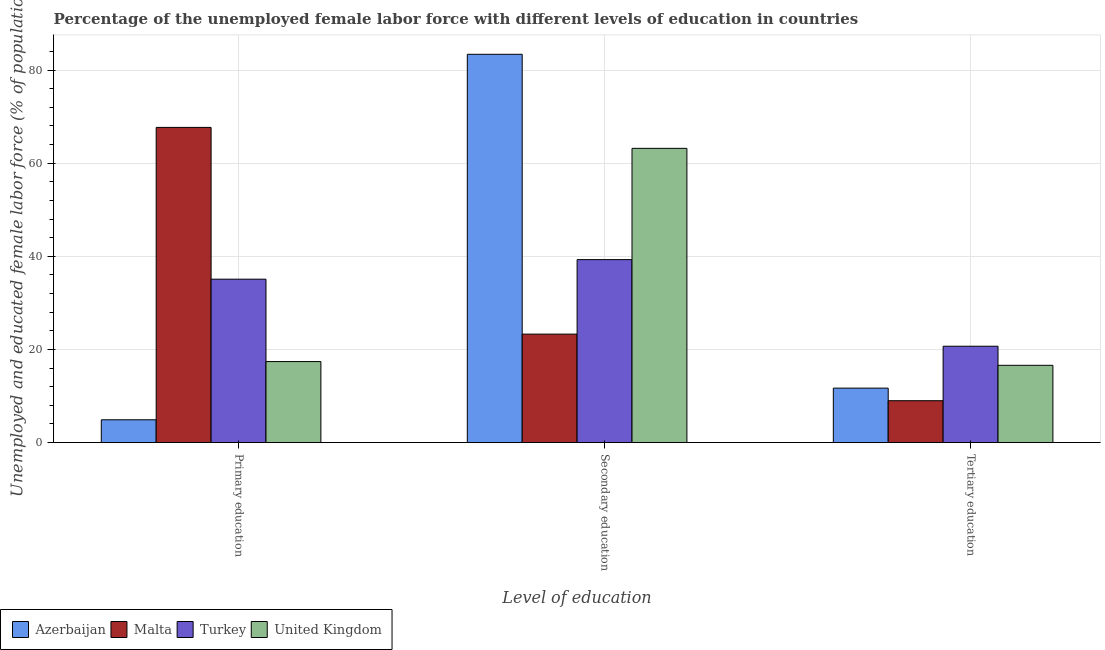Are the number of bars per tick equal to the number of legend labels?
Your response must be concise. Yes. Are the number of bars on each tick of the X-axis equal?
Offer a terse response. Yes. How many bars are there on the 3rd tick from the right?
Your response must be concise. 4. What is the label of the 3rd group of bars from the left?
Ensure brevity in your answer.  Tertiary education. What is the percentage of female labor force who received primary education in Azerbaijan?
Your response must be concise. 4.9. Across all countries, what is the maximum percentage of female labor force who received primary education?
Your answer should be very brief. 67.7. Across all countries, what is the minimum percentage of female labor force who received secondary education?
Ensure brevity in your answer.  23.3. In which country was the percentage of female labor force who received secondary education maximum?
Provide a short and direct response. Azerbaijan. In which country was the percentage of female labor force who received primary education minimum?
Provide a short and direct response. Azerbaijan. What is the total percentage of female labor force who received primary education in the graph?
Provide a succinct answer. 125.1. What is the difference between the percentage of female labor force who received primary education in Turkey and that in Malta?
Offer a terse response. -32.6. What is the difference between the percentage of female labor force who received tertiary education in Malta and the percentage of female labor force who received secondary education in United Kingdom?
Offer a very short reply. -54.2. What is the average percentage of female labor force who received tertiary education per country?
Your response must be concise. 14.5. What is the difference between the percentage of female labor force who received secondary education and percentage of female labor force who received tertiary education in United Kingdom?
Provide a short and direct response. 46.6. What is the ratio of the percentage of female labor force who received tertiary education in Malta to that in United Kingdom?
Your answer should be very brief. 0.54. What is the difference between the highest and the second highest percentage of female labor force who received primary education?
Your answer should be compact. 32.6. What is the difference between the highest and the lowest percentage of female labor force who received primary education?
Make the answer very short. 62.8. In how many countries, is the percentage of female labor force who received primary education greater than the average percentage of female labor force who received primary education taken over all countries?
Offer a terse response. 2. What is the difference between two consecutive major ticks on the Y-axis?
Your response must be concise. 20. How are the legend labels stacked?
Your answer should be compact. Horizontal. What is the title of the graph?
Ensure brevity in your answer.  Percentage of the unemployed female labor force with different levels of education in countries. What is the label or title of the X-axis?
Give a very brief answer. Level of education. What is the label or title of the Y-axis?
Offer a very short reply. Unemployed and educated female labor force (% of population). What is the Unemployed and educated female labor force (% of population) of Azerbaijan in Primary education?
Your response must be concise. 4.9. What is the Unemployed and educated female labor force (% of population) in Malta in Primary education?
Your response must be concise. 67.7. What is the Unemployed and educated female labor force (% of population) in Turkey in Primary education?
Provide a short and direct response. 35.1. What is the Unemployed and educated female labor force (% of population) in United Kingdom in Primary education?
Your answer should be compact. 17.4. What is the Unemployed and educated female labor force (% of population) in Azerbaijan in Secondary education?
Your answer should be very brief. 83.4. What is the Unemployed and educated female labor force (% of population) of Malta in Secondary education?
Provide a succinct answer. 23.3. What is the Unemployed and educated female labor force (% of population) in Turkey in Secondary education?
Provide a short and direct response. 39.3. What is the Unemployed and educated female labor force (% of population) in United Kingdom in Secondary education?
Provide a succinct answer. 63.2. What is the Unemployed and educated female labor force (% of population) of Azerbaijan in Tertiary education?
Keep it short and to the point. 11.7. What is the Unemployed and educated female labor force (% of population) in Turkey in Tertiary education?
Offer a terse response. 20.7. What is the Unemployed and educated female labor force (% of population) in United Kingdom in Tertiary education?
Your response must be concise. 16.6. Across all Level of education, what is the maximum Unemployed and educated female labor force (% of population) in Azerbaijan?
Keep it short and to the point. 83.4. Across all Level of education, what is the maximum Unemployed and educated female labor force (% of population) of Malta?
Your answer should be very brief. 67.7. Across all Level of education, what is the maximum Unemployed and educated female labor force (% of population) of Turkey?
Provide a short and direct response. 39.3. Across all Level of education, what is the maximum Unemployed and educated female labor force (% of population) of United Kingdom?
Offer a very short reply. 63.2. Across all Level of education, what is the minimum Unemployed and educated female labor force (% of population) of Azerbaijan?
Offer a terse response. 4.9. Across all Level of education, what is the minimum Unemployed and educated female labor force (% of population) of Turkey?
Offer a very short reply. 20.7. Across all Level of education, what is the minimum Unemployed and educated female labor force (% of population) of United Kingdom?
Give a very brief answer. 16.6. What is the total Unemployed and educated female labor force (% of population) of Azerbaijan in the graph?
Offer a very short reply. 100. What is the total Unemployed and educated female labor force (% of population) of Turkey in the graph?
Make the answer very short. 95.1. What is the total Unemployed and educated female labor force (% of population) of United Kingdom in the graph?
Ensure brevity in your answer.  97.2. What is the difference between the Unemployed and educated female labor force (% of population) in Azerbaijan in Primary education and that in Secondary education?
Provide a succinct answer. -78.5. What is the difference between the Unemployed and educated female labor force (% of population) of Malta in Primary education and that in Secondary education?
Offer a terse response. 44.4. What is the difference between the Unemployed and educated female labor force (% of population) of Turkey in Primary education and that in Secondary education?
Offer a very short reply. -4.2. What is the difference between the Unemployed and educated female labor force (% of population) in United Kingdom in Primary education and that in Secondary education?
Keep it short and to the point. -45.8. What is the difference between the Unemployed and educated female labor force (% of population) in Malta in Primary education and that in Tertiary education?
Your answer should be compact. 58.7. What is the difference between the Unemployed and educated female labor force (% of population) of Turkey in Primary education and that in Tertiary education?
Make the answer very short. 14.4. What is the difference between the Unemployed and educated female labor force (% of population) of United Kingdom in Primary education and that in Tertiary education?
Keep it short and to the point. 0.8. What is the difference between the Unemployed and educated female labor force (% of population) of Azerbaijan in Secondary education and that in Tertiary education?
Your answer should be compact. 71.7. What is the difference between the Unemployed and educated female labor force (% of population) in United Kingdom in Secondary education and that in Tertiary education?
Keep it short and to the point. 46.6. What is the difference between the Unemployed and educated female labor force (% of population) in Azerbaijan in Primary education and the Unemployed and educated female labor force (% of population) in Malta in Secondary education?
Your answer should be compact. -18.4. What is the difference between the Unemployed and educated female labor force (% of population) of Azerbaijan in Primary education and the Unemployed and educated female labor force (% of population) of Turkey in Secondary education?
Your response must be concise. -34.4. What is the difference between the Unemployed and educated female labor force (% of population) in Azerbaijan in Primary education and the Unemployed and educated female labor force (% of population) in United Kingdom in Secondary education?
Give a very brief answer. -58.3. What is the difference between the Unemployed and educated female labor force (% of population) of Malta in Primary education and the Unemployed and educated female labor force (% of population) of Turkey in Secondary education?
Give a very brief answer. 28.4. What is the difference between the Unemployed and educated female labor force (% of population) in Turkey in Primary education and the Unemployed and educated female labor force (% of population) in United Kingdom in Secondary education?
Your answer should be very brief. -28.1. What is the difference between the Unemployed and educated female labor force (% of population) of Azerbaijan in Primary education and the Unemployed and educated female labor force (% of population) of Turkey in Tertiary education?
Make the answer very short. -15.8. What is the difference between the Unemployed and educated female labor force (% of population) in Azerbaijan in Primary education and the Unemployed and educated female labor force (% of population) in United Kingdom in Tertiary education?
Provide a succinct answer. -11.7. What is the difference between the Unemployed and educated female labor force (% of population) of Malta in Primary education and the Unemployed and educated female labor force (% of population) of Turkey in Tertiary education?
Give a very brief answer. 47. What is the difference between the Unemployed and educated female labor force (% of population) in Malta in Primary education and the Unemployed and educated female labor force (% of population) in United Kingdom in Tertiary education?
Your answer should be very brief. 51.1. What is the difference between the Unemployed and educated female labor force (% of population) of Turkey in Primary education and the Unemployed and educated female labor force (% of population) of United Kingdom in Tertiary education?
Keep it short and to the point. 18.5. What is the difference between the Unemployed and educated female labor force (% of population) in Azerbaijan in Secondary education and the Unemployed and educated female labor force (% of population) in Malta in Tertiary education?
Offer a very short reply. 74.4. What is the difference between the Unemployed and educated female labor force (% of population) of Azerbaijan in Secondary education and the Unemployed and educated female labor force (% of population) of Turkey in Tertiary education?
Offer a terse response. 62.7. What is the difference between the Unemployed and educated female labor force (% of population) of Azerbaijan in Secondary education and the Unemployed and educated female labor force (% of population) of United Kingdom in Tertiary education?
Your answer should be very brief. 66.8. What is the difference between the Unemployed and educated female labor force (% of population) of Turkey in Secondary education and the Unemployed and educated female labor force (% of population) of United Kingdom in Tertiary education?
Your response must be concise. 22.7. What is the average Unemployed and educated female labor force (% of population) of Azerbaijan per Level of education?
Give a very brief answer. 33.33. What is the average Unemployed and educated female labor force (% of population) in Malta per Level of education?
Offer a terse response. 33.33. What is the average Unemployed and educated female labor force (% of population) of Turkey per Level of education?
Your response must be concise. 31.7. What is the average Unemployed and educated female labor force (% of population) in United Kingdom per Level of education?
Provide a succinct answer. 32.4. What is the difference between the Unemployed and educated female labor force (% of population) in Azerbaijan and Unemployed and educated female labor force (% of population) in Malta in Primary education?
Ensure brevity in your answer.  -62.8. What is the difference between the Unemployed and educated female labor force (% of population) in Azerbaijan and Unemployed and educated female labor force (% of population) in Turkey in Primary education?
Provide a succinct answer. -30.2. What is the difference between the Unemployed and educated female labor force (% of population) in Malta and Unemployed and educated female labor force (% of population) in Turkey in Primary education?
Make the answer very short. 32.6. What is the difference between the Unemployed and educated female labor force (% of population) of Malta and Unemployed and educated female labor force (% of population) of United Kingdom in Primary education?
Ensure brevity in your answer.  50.3. What is the difference between the Unemployed and educated female labor force (% of population) of Turkey and Unemployed and educated female labor force (% of population) of United Kingdom in Primary education?
Offer a very short reply. 17.7. What is the difference between the Unemployed and educated female labor force (% of population) of Azerbaijan and Unemployed and educated female labor force (% of population) of Malta in Secondary education?
Your response must be concise. 60.1. What is the difference between the Unemployed and educated female labor force (% of population) of Azerbaijan and Unemployed and educated female labor force (% of population) of Turkey in Secondary education?
Make the answer very short. 44.1. What is the difference between the Unemployed and educated female labor force (% of population) in Azerbaijan and Unemployed and educated female labor force (% of population) in United Kingdom in Secondary education?
Your answer should be very brief. 20.2. What is the difference between the Unemployed and educated female labor force (% of population) in Malta and Unemployed and educated female labor force (% of population) in United Kingdom in Secondary education?
Make the answer very short. -39.9. What is the difference between the Unemployed and educated female labor force (% of population) in Turkey and Unemployed and educated female labor force (% of population) in United Kingdom in Secondary education?
Offer a very short reply. -23.9. What is the difference between the Unemployed and educated female labor force (% of population) of Azerbaijan and Unemployed and educated female labor force (% of population) of Malta in Tertiary education?
Your answer should be compact. 2.7. What is the difference between the Unemployed and educated female labor force (% of population) in Malta and Unemployed and educated female labor force (% of population) in United Kingdom in Tertiary education?
Ensure brevity in your answer.  -7.6. What is the difference between the Unemployed and educated female labor force (% of population) in Turkey and Unemployed and educated female labor force (% of population) in United Kingdom in Tertiary education?
Your response must be concise. 4.1. What is the ratio of the Unemployed and educated female labor force (% of population) in Azerbaijan in Primary education to that in Secondary education?
Your response must be concise. 0.06. What is the ratio of the Unemployed and educated female labor force (% of population) of Malta in Primary education to that in Secondary education?
Provide a succinct answer. 2.91. What is the ratio of the Unemployed and educated female labor force (% of population) in Turkey in Primary education to that in Secondary education?
Your answer should be compact. 0.89. What is the ratio of the Unemployed and educated female labor force (% of population) of United Kingdom in Primary education to that in Secondary education?
Your answer should be very brief. 0.28. What is the ratio of the Unemployed and educated female labor force (% of population) in Azerbaijan in Primary education to that in Tertiary education?
Your response must be concise. 0.42. What is the ratio of the Unemployed and educated female labor force (% of population) in Malta in Primary education to that in Tertiary education?
Give a very brief answer. 7.52. What is the ratio of the Unemployed and educated female labor force (% of population) of Turkey in Primary education to that in Tertiary education?
Your answer should be very brief. 1.7. What is the ratio of the Unemployed and educated female labor force (% of population) of United Kingdom in Primary education to that in Tertiary education?
Your answer should be compact. 1.05. What is the ratio of the Unemployed and educated female labor force (% of population) of Azerbaijan in Secondary education to that in Tertiary education?
Provide a short and direct response. 7.13. What is the ratio of the Unemployed and educated female labor force (% of population) in Malta in Secondary education to that in Tertiary education?
Your answer should be very brief. 2.59. What is the ratio of the Unemployed and educated female labor force (% of population) of Turkey in Secondary education to that in Tertiary education?
Provide a succinct answer. 1.9. What is the ratio of the Unemployed and educated female labor force (% of population) of United Kingdom in Secondary education to that in Tertiary education?
Make the answer very short. 3.81. What is the difference between the highest and the second highest Unemployed and educated female labor force (% of population) in Azerbaijan?
Offer a terse response. 71.7. What is the difference between the highest and the second highest Unemployed and educated female labor force (% of population) of Malta?
Give a very brief answer. 44.4. What is the difference between the highest and the second highest Unemployed and educated female labor force (% of population) of United Kingdom?
Offer a terse response. 45.8. What is the difference between the highest and the lowest Unemployed and educated female labor force (% of population) of Azerbaijan?
Keep it short and to the point. 78.5. What is the difference between the highest and the lowest Unemployed and educated female labor force (% of population) of Malta?
Make the answer very short. 58.7. What is the difference between the highest and the lowest Unemployed and educated female labor force (% of population) in Turkey?
Offer a very short reply. 18.6. What is the difference between the highest and the lowest Unemployed and educated female labor force (% of population) in United Kingdom?
Your answer should be compact. 46.6. 